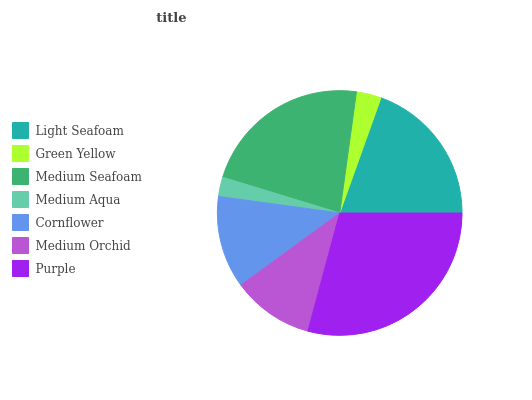Is Medium Aqua the minimum?
Answer yes or no. Yes. Is Purple the maximum?
Answer yes or no. Yes. Is Green Yellow the minimum?
Answer yes or no. No. Is Green Yellow the maximum?
Answer yes or no. No. Is Light Seafoam greater than Green Yellow?
Answer yes or no. Yes. Is Green Yellow less than Light Seafoam?
Answer yes or no. Yes. Is Green Yellow greater than Light Seafoam?
Answer yes or no. No. Is Light Seafoam less than Green Yellow?
Answer yes or no. No. Is Cornflower the high median?
Answer yes or no. Yes. Is Cornflower the low median?
Answer yes or no. Yes. Is Light Seafoam the high median?
Answer yes or no. No. Is Light Seafoam the low median?
Answer yes or no. No. 